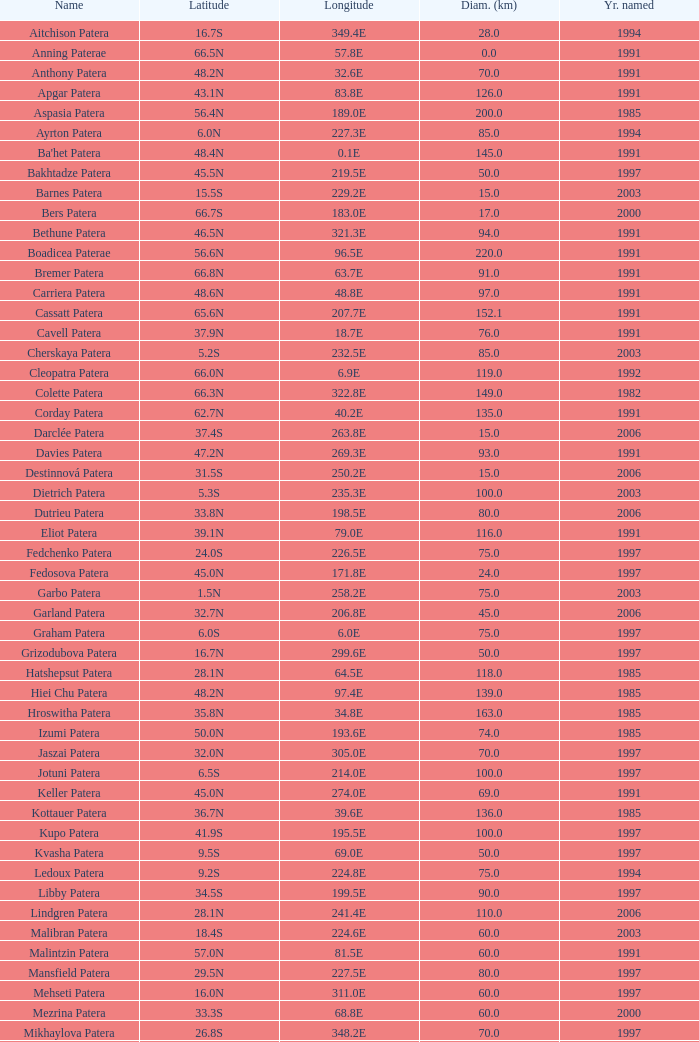What is Longitude, when Name is Raskova Paterae? 222.8E. 